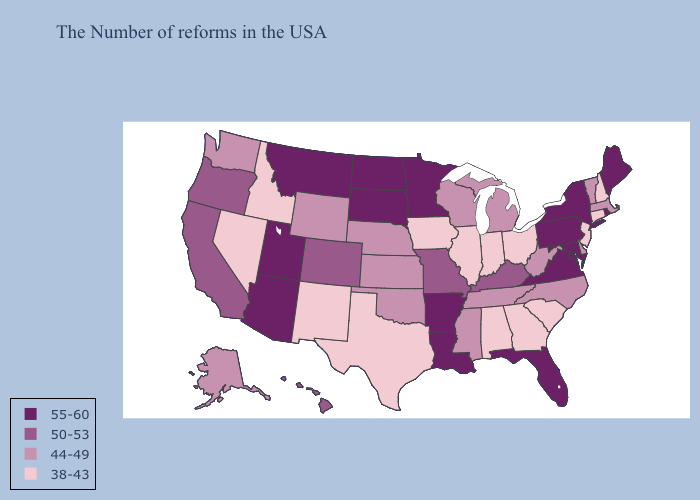Does Oklahoma have the lowest value in the USA?
Answer briefly. No. Does Pennsylvania have the lowest value in the Northeast?
Concise answer only. No. Which states have the lowest value in the USA?
Be succinct. New Hampshire, Connecticut, New Jersey, South Carolina, Ohio, Georgia, Indiana, Alabama, Illinois, Iowa, Texas, New Mexico, Idaho, Nevada. What is the lowest value in the West?
Give a very brief answer. 38-43. Does New Hampshire have the lowest value in the USA?
Concise answer only. Yes. Name the states that have a value in the range 44-49?
Be succinct. Massachusetts, Vermont, Delaware, North Carolina, West Virginia, Michigan, Tennessee, Wisconsin, Mississippi, Kansas, Nebraska, Oklahoma, Wyoming, Washington, Alaska. What is the highest value in states that border Vermont?
Quick response, please. 55-60. Does Louisiana have the lowest value in the USA?
Give a very brief answer. No. What is the value of Utah?
Give a very brief answer. 55-60. Among the states that border Minnesota , does Wisconsin have the lowest value?
Quick response, please. No. Name the states that have a value in the range 50-53?
Keep it brief. Kentucky, Missouri, Colorado, California, Oregon, Hawaii. Name the states that have a value in the range 38-43?
Keep it brief. New Hampshire, Connecticut, New Jersey, South Carolina, Ohio, Georgia, Indiana, Alabama, Illinois, Iowa, Texas, New Mexico, Idaho, Nevada. Which states have the lowest value in the USA?
Be succinct. New Hampshire, Connecticut, New Jersey, South Carolina, Ohio, Georgia, Indiana, Alabama, Illinois, Iowa, Texas, New Mexico, Idaho, Nevada. Does the first symbol in the legend represent the smallest category?
Answer briefly. No. Does Texas have the lowest value in the South?
Write a very short answer. Yes. 